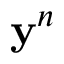Convert formula to latex. <formula><loc_0><loc_0><loc_500><loc_500>y ^ { n }</formula> 